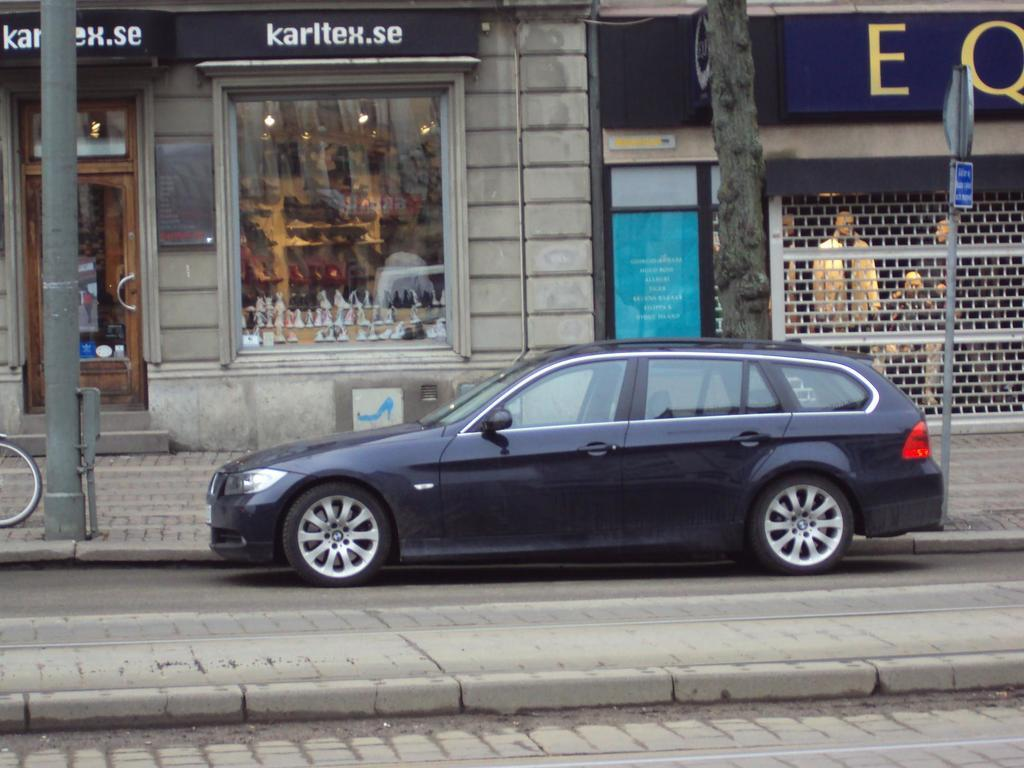What type of vehicle is in the image? There is a black color car in the image. What is on the ground in the image? There is a bicycle on the ground in the image. What can be seen in the background of the image? There is a building, a glass wall, people, a board, and other objects visible in the background of the image. Can you see any fangs on the car in the image? There are no fangs present on the car in the image. Is there a veil covering the bicycle in the image? There is no veil present in the image; the bicycle is visible on the ground. 